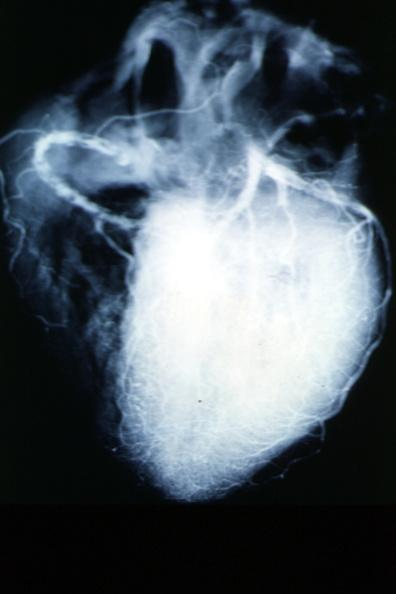s lower chest and abdomen anterior present?
Answer the question using a single word or phrase. No 